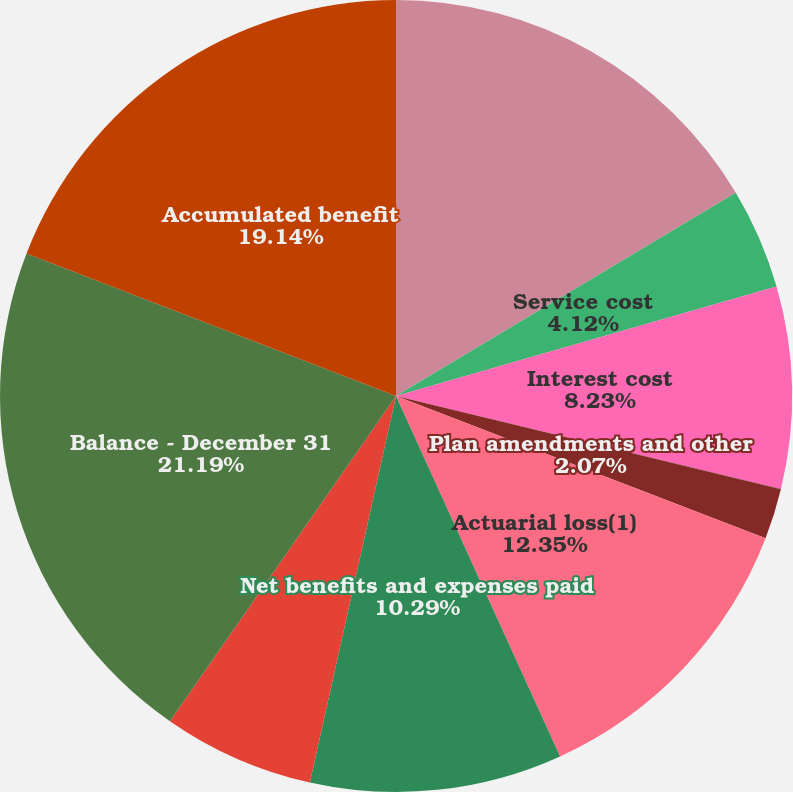<chart> <loc_0><loc_0><loc_500><loc_500><pie_chart><fcel>Balance - January 1<fcel>Service cost<fcel>Interest cost<fcel>Employee contributions<fcel>Plan amendments and other<fcel>Actuarial loss(1)<fcel>Net benefits and expenses paid<fcel>Currency translation impact(2)<fcel>Balance - December 31<fcel>Accumulated benefit<nl><fcel>16.42%<fcel>4.12%<fcel>8.23%<fcel>0.01%<fcel>2.07%<fcel>12.35%<fcel>10.29%<fcel>6.18%<fcel>21.19%<fcel>19.14%<nl></chart> 